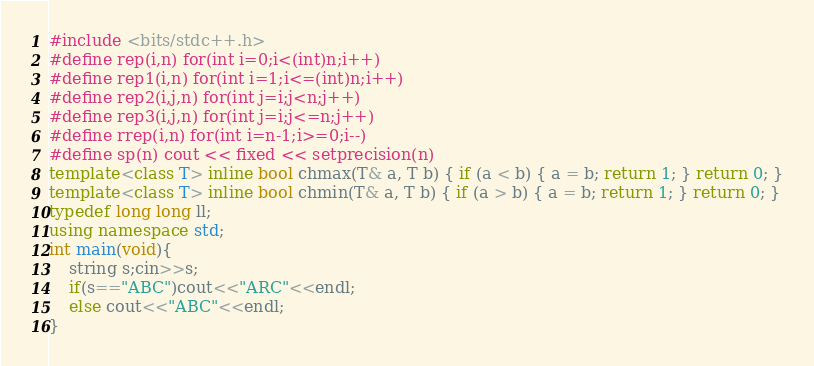Convert code to text. <code><loc_0><loc_0><loc_500><loc_500><_C++_>#include <bits/stdc++.h>
#define rep(i,n) for(int i=0;i<(int)n;i++)
#define rep1(i,n) for(int i=1;i<=(int)n;i++)
#define rep2(i,j,n) for(int j=i;j<n;j++)
#define rep3(i,j,n) for(int j=i;j<=n;j++)
#define rrep(i,n) for(int i=n-1;i>=0;i--)
#define sp(n) cout << fixed << setprecision(n)
template<class T> inline bool chmax(T& a, T b) { if (a < b) { a = b; return 1; } return 0; }
template<class T> inline bool chmin(T& a, T b) { if (a > b) { a = b; return 1; } return 0; }
typedef long long ll;
using namespace std;
int main(void){
    string s;cin>>s;
    if(s=="ABC")cout<<"ARC"<<endl;
    else cout<<"ABC"<<endl;
}</code> 